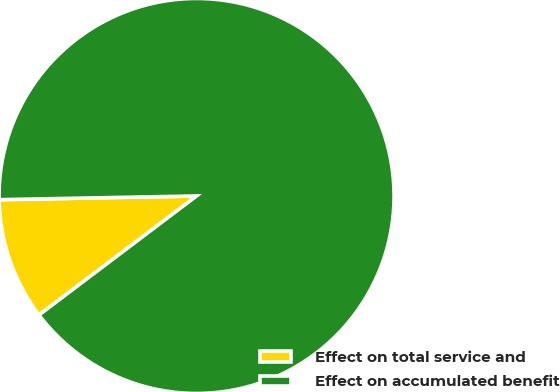Convert chart. <chart><loc_0><loc_0><loc_500><loc_500><pie_chart><fcel>Effect on total service and<fcel>Effect on accumulated benefit<nl><fcel>10.0%<fcel>90.0%<nl></chart> 